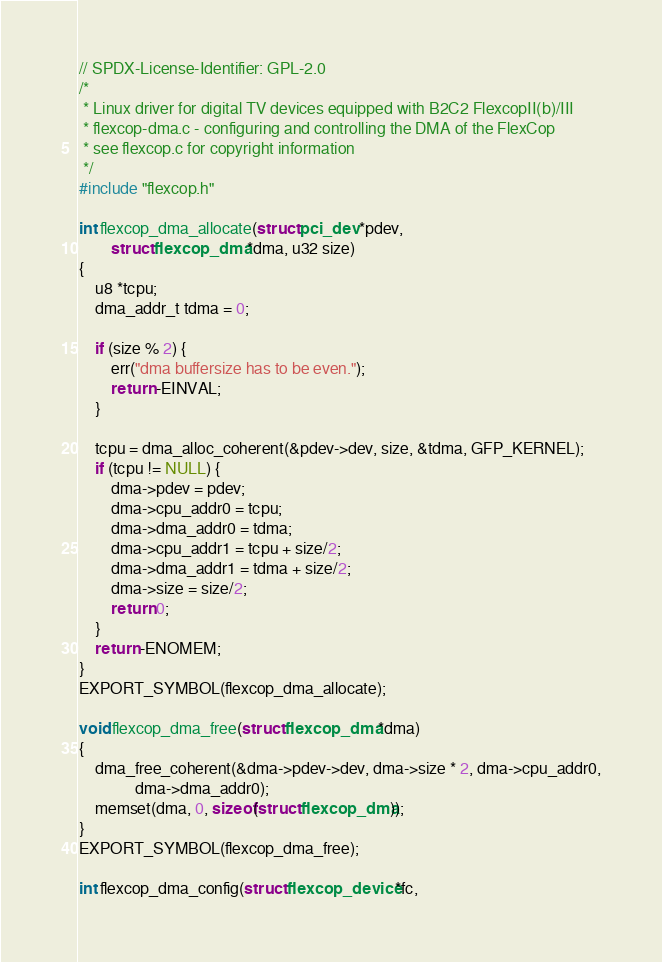<code> <loc_0><loc_0><loc_500><loc_500><_C_>// SPDX-License-Identifier: GPL-2.0
/*
 * Linux driver for digital TV devices equipped with B2C2 FlexcopII(b)/III
 * flexcop-dma.c - configuring and controlling the DMA of the FlexCop
 * see flexcop.c for copyright information
 */
#include "flexcop.h"

int flexcop_dma_allocate(struct pci_dev *pdev,
		struct flexcop_dma *dma, u32 size)
{
	u8 *tcpu;
	dma_addr_t tdma = 0;

	if (size % 2) {
		err("dma buffersize has to be even.");
		return -EINVAL;
	}

	tcpu = dma_alloc_coherent(&pdev->dev, size, &tdma, GFP_KERNEL);
	if (tcpu != NULL) {
		dma->pdev = pdev;
		dma->cpu_addr0 = tcpu;
		dma->dma_addr0 = tdma;
		dma->cpu_addr1 = tcpu + size/2;
		dma->dma_addr1 = tdma + size/2;
		dma->size = size/2;
		return 0;
	}
	return -ENOMEM;
}
EXPORT_SYMBOL(flexcop_dma_allocate);

void flexcop_dma_free(struct flexcop_dma *dma)
{
	dma_free_coherent(&dma->pdev->dev, dma->size * 2, dma->cpu_addr0,
			  dma->dma_addr0);
	memset(dma, 0, sizeof(struct flexcop_dma));
}
EXPORT_SYMBOL(flexcop_dma_free);

int flexcop_dma_config(struct flexcop_device *fc,</code> 